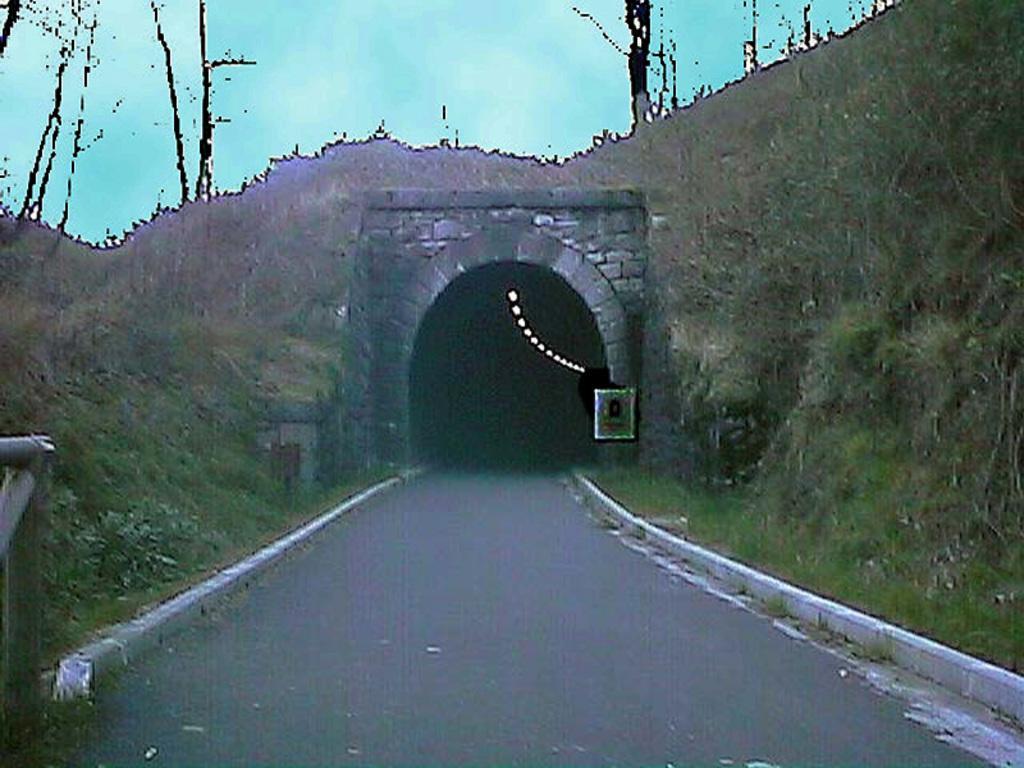Can you describe this image briefly? In this image we can see road, tunnel, lights on the tunnel roof, grass on the ground and clouds in the sky. On the left side we can see metal object. 